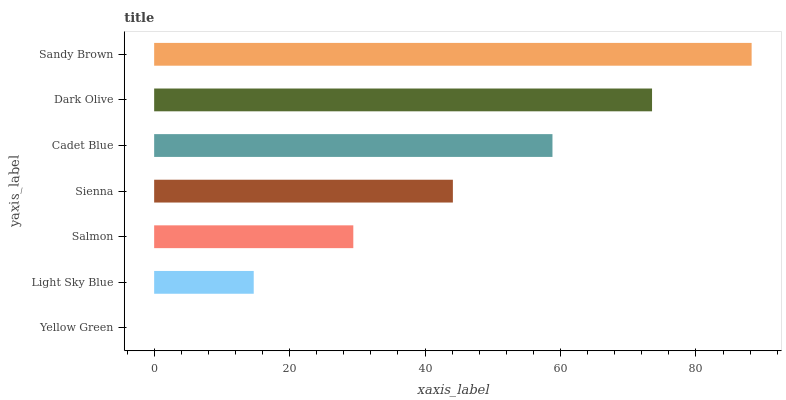Is Yellow Green the minimum?
Answer yes or no. Yes. Is Sandy Brown the maximum?
Answer yes or no. Yes. Is Light Sky Blue the minimum?
Answer yes or no. No. Is Light Sky Blue the maximum?
Answer yes or no. No. Is Light Sky Blue greater than Yellow Green?
Answer yes or no. Yes. Is Yellow Green less than Light Sky Blue?
Answer yes or no. Yes. Is Yellow Green greater than Light Sky Blue?
Answer yes or no. No. Is Light Sky Blue less than Yellow Green?
Answer yes or no. No. Is Sienna the high median?
Answer yes or no. Yes. Is Sienna the low median?
Answer yes or no. Yes. Is Dark Olive the high median?
Answer yes or no. No. Is Sandy Brown the low median?
Answer yes or no. No. 